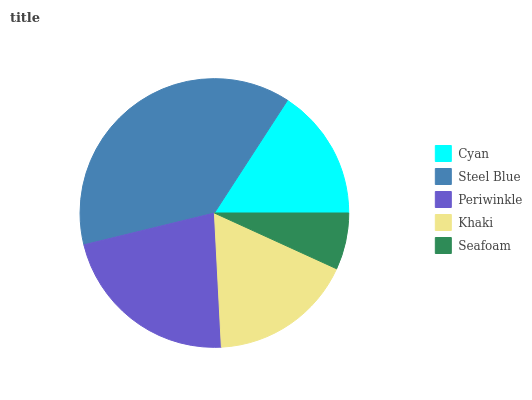Is Seafoam the minimum?
Answer yes or no. Yes. Is Steel Blue the maximum?
Answer yes or no. Yes. Is Periwinkle the minimum?
Answer yes or no. No. Is Periwinkle the maximum?
Answer yes or no. No. Is Steel Blue greater than Periwinkle?
Answer yes or no. Yes. Is Periwinkle less than Steel Blue?
Answer yes or no. Yes. Is Periwinkle greater than Steel Blue?
Answer yes or no. No. Is Steel Blue less than Periwinkle?
Answer yes or no. No. Is Khaki the high median?
Answer yes or no. Yes. Is Khaki the low median?
Answer yes or no. Yes. Is Periwinkle the high median?
Answer yes or no. No. Is Steel Blue the low median?
Answer yes or no. No. 